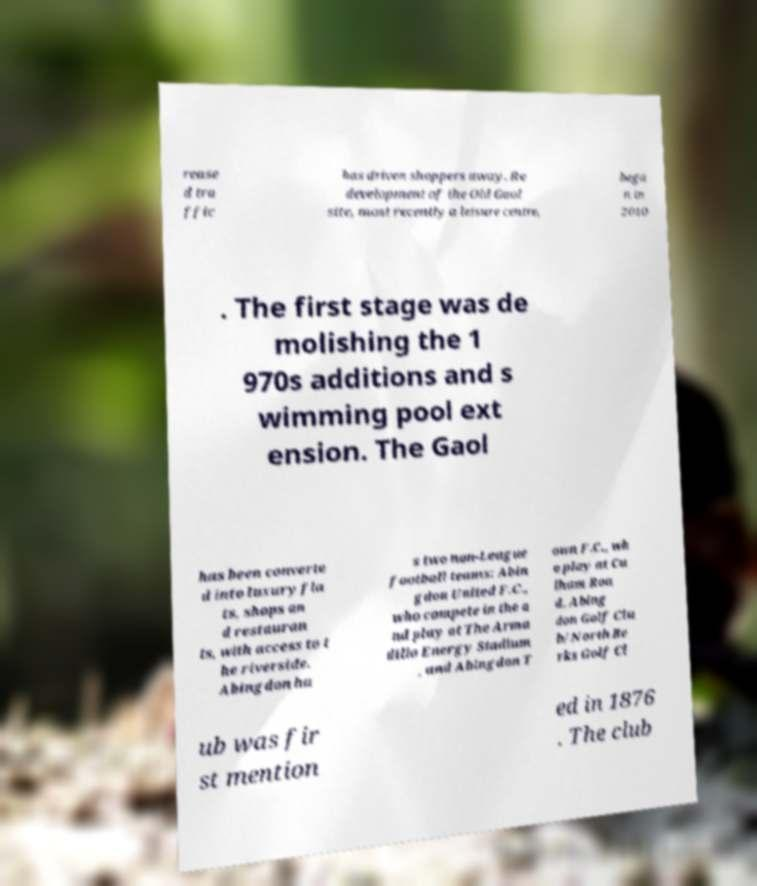Can you read and provide the text displayed in the image?This photo seems to have some interesting text. Can you extract and type it out for me? rease d tra ffic has driven shoppers away. Re development of the Old Gaol site, most recently a leisure centre, bega n in 2010 . The first stage was de molishing the 1 970s additions and s wimming pool ext ension. The Gaol has been converte d into luxury fla ts, shops an d restauran ts, with access to t he riverside. Abingdon ha s two non-League football teams: Abin gdon United F.C., who compete in the a nd play at The Arma dillo Energy Stadium , and Abingdon T own F.C., wh o play at Cu lham Roa d. Abing don Golf Clu b/North Be rks Golf Cl ub was fir st mention ed in 1876 . The club 